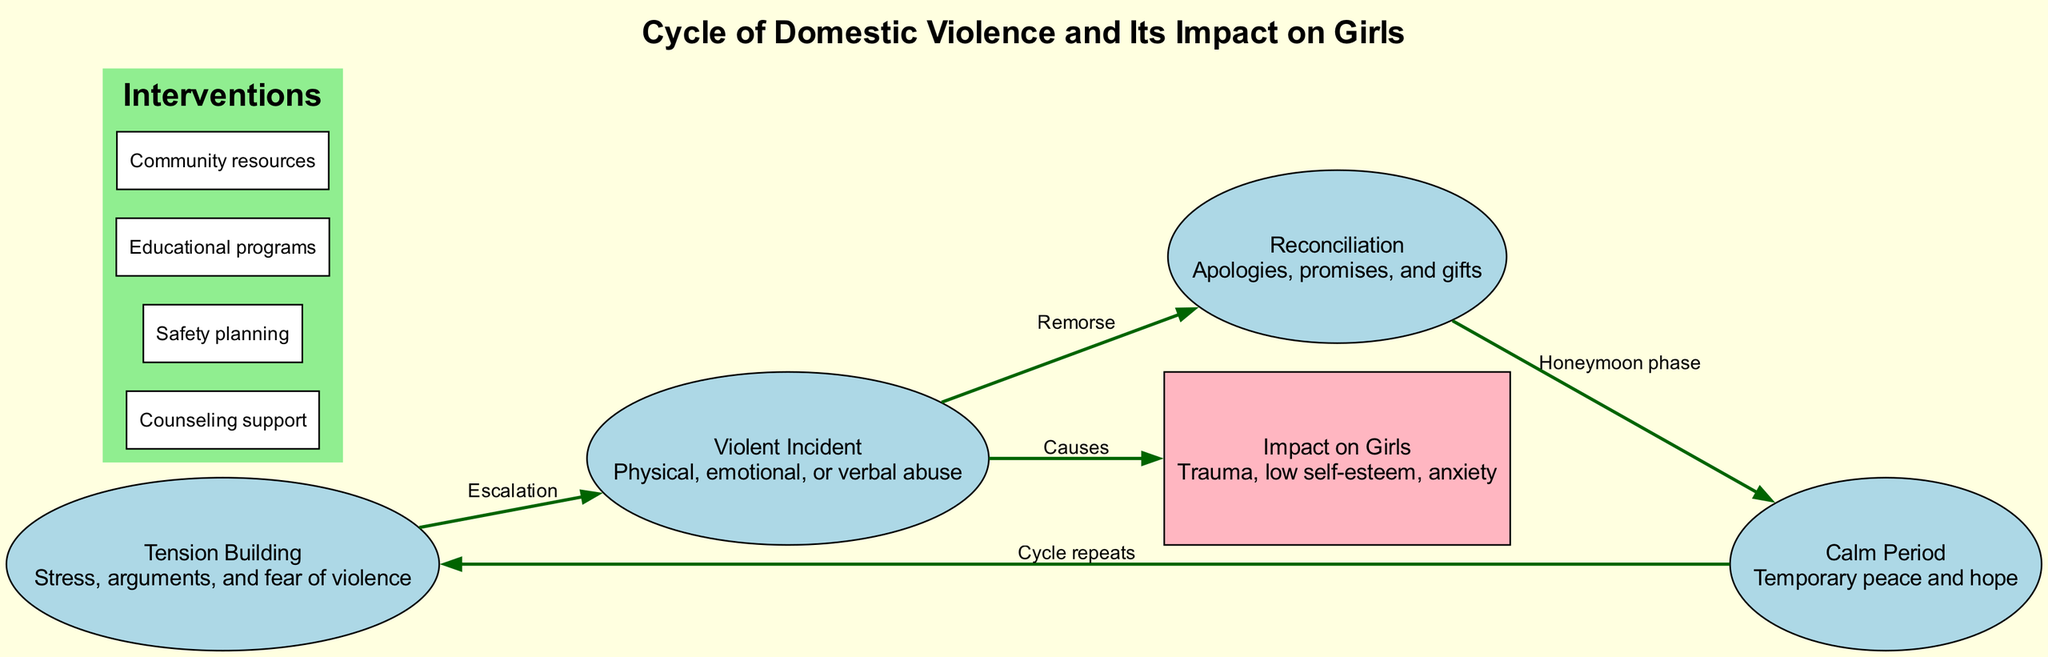What are the four main stages in the cycle of domestic violence? The diagram lists the stages as "Tension Building," "Violent Incident," "Reconciliation," and "Calm Period." These stages are visually represented in sequential order and are critical to understanding the cycle.
Answer: Tension Building, Violent Incident, Reconciliation, Calm Period Which node shows the impact on girls? The node labeled "Impact on Girls" is positioned at the bottom of the diagram and indicates the consequences of the cycle of domestic violence. It is the only node in a box shape with a distinct color, emphasizing its importance.
Answer: Impact on Girls How many edges are connected to the "Violent Incident" node? The "Violent Incident" node has two edges: one leading to the "Reconciliation" node and another leading to the "Impact on Girls" node. Each edge represents a relationship or consequence of the violent incident.
Answer: 2 What is the role of the edge labeled "Remorse"? The edge labeled "Remorse" connects the "Violent Incident" node to the "Reconciliation" node, indicating that after a violent incident, there is often a phase where the abuser expresses remorse. This connection emphasizes the emotional dynamics in the cycle.
Answer: Connects Violent Incident to Reconciliation Which intervention is meant to provide immediate support? "Counseling support" is listed as an intervention aimed at helping victims cope with their experiences, offering a direct method for immediate assistance during crises.
Answer: Counseling support What connects the "Calm Period" back to "Tension Building"? The edge labeled "Cycle repeats" connects these two nodes, indicating that after a calm period, there is a return to tension building, thus completing the cycle of domestic violence. This shows the cyclical nature of the situation.
Answer: Cycle repeats How does the "Violent Incident" directly affect girls? The edge from "Violent Incident" to "Impact on Girls" demonstrates that the violent incident causes trauma, low self-esteem, and anxiety, indicating a direct negative impact on girls' psychological and emotional well-being.
Answer: Causes What shape represents the "Reconciliation" node? The "Reconciliation" node is shaped as an ellipse, as indicated by its visual representation in the diagram, showing it's part of the cyclical process of domestic violence rather than an endpoint.
Answer: Ellipse 